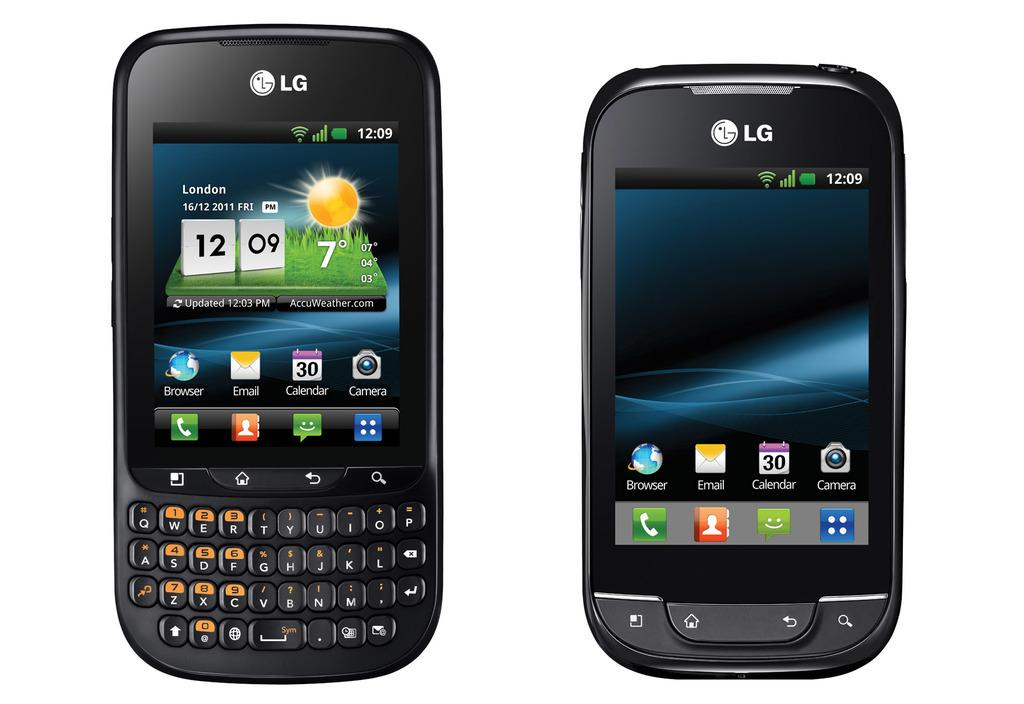What electronic device is present in the image? There is a cell phone in the image. What feature is visible on the cell phone? The cell phone has a screen. What can be seen on the screen of the cell phone? There are images, text, and numbers on the screen. Are there any physical controls on the cell phone? Yes, there are buttons on the cell phone. What type of engine is visible in the image? There is no engine present in the image; it features a cell phone. Is there a vest being worn by anyone in the image? There is no person or vest visible in the image. 